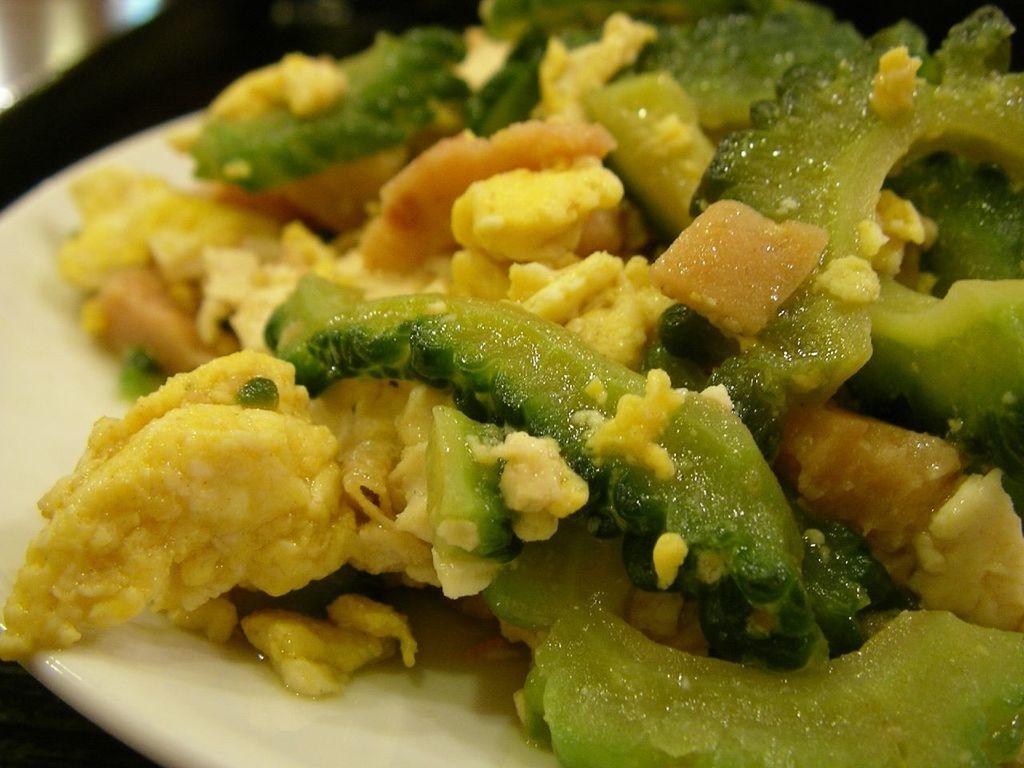In one or two sentences, can you explain what this image depicts? In this picture I can see food in the plate and looks like a table in the background. 